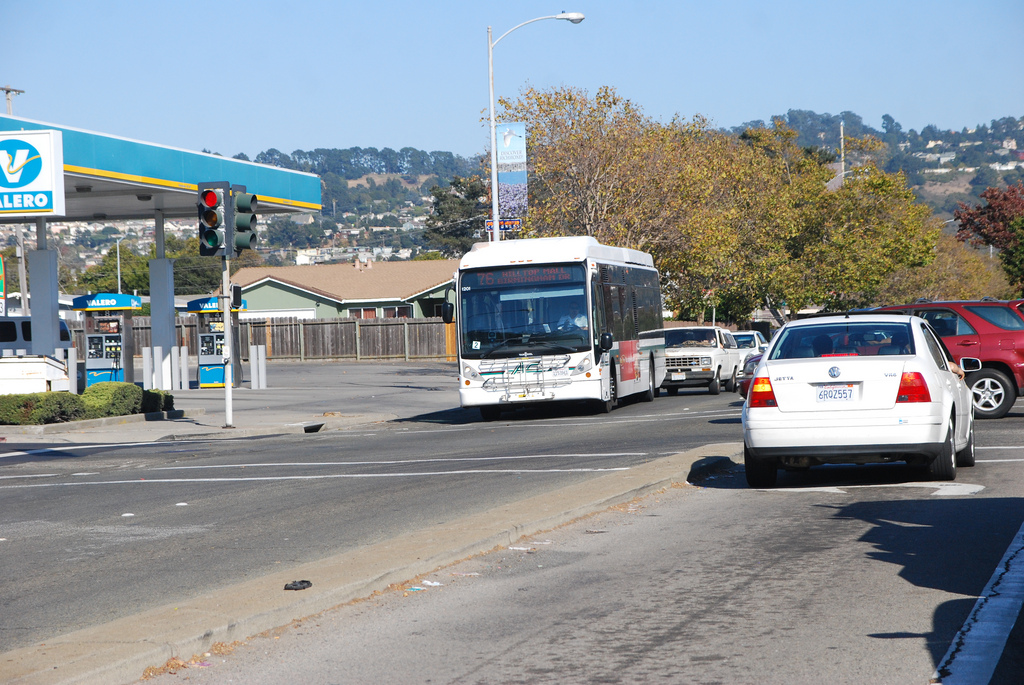What's the fence made of? The fence in the image is made of wooden planks, which are commonly used in residential fencing. 